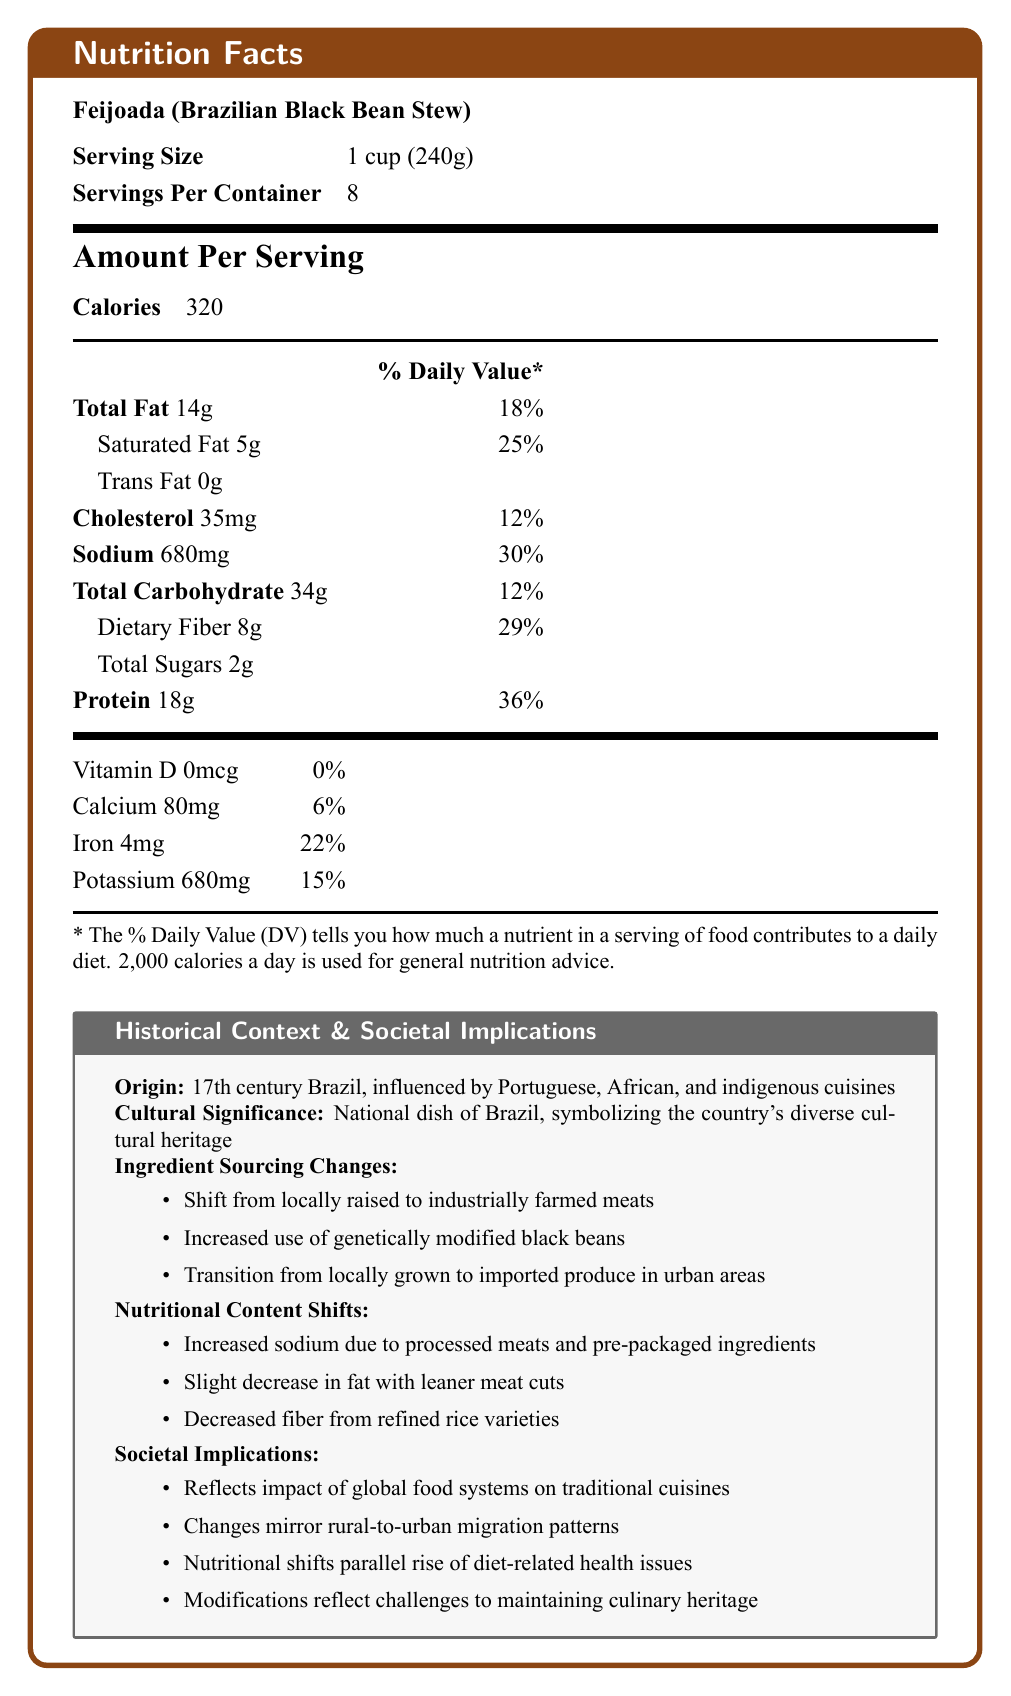what is the serving size of Feijoada (Brazilian Black Bean Stew)? The serving size is clearly mentioned in the Nutrition Facts section as "1 cup (240g)".
Answer: 1 cup (240g) how many servings are there per container? The document states "Servings Per Container: 8".
Answer: 8 what is the total fat content per serving and its daily value percentage? The document lists the total fat as 14g and the % Daily Value as 18%.
Answer: 14g, 18% how much protein is in one serving of Feijoada? The amount of protein per serving is mentioned as 18g.
Answer: 18g which nutrient has the highest % daily value? A. Iron B. Sodium C. Protein D. Saturated Fat Saturated Fat has 25% DV, which is the highest percentage compared to others listed.
Answer: D what is the historical origin of Feijoada? This information is provided under the "Historical Context" section.
Answer: 17th century Brazil, influenced by Portuguese, African, and indigenous cuisines which factors have contributed to changes in the nutritional content of Feijoada? A. Urbanization B. Globalization C. Ingredient sourcing changes D. All of the above All options (Urbanization, Globalization, and Ingredient sourcing changes) are mentioned as factors in the "Societal Implications" section.
Answer: D has the sodium content increased or decreased in modern Feijoada? The document states that sodium has increased due to the use of processed meats and pre-packaged ingredients.
Answer: Increased True or False: Feijoada has become more health-conscious over time by reducing fat content. The document mentions a slight decrease in fat due to the use of leaner cuts of meat, which indicates a move towards being more health-conscious.
Answer: True how does the shift in ingredient sourcing reflect broader societal changes? The document explains that changes in ingredient sourcing are tied to the impact of global food systems, rural-to-urban migration patterns, and the broader cultural shifts in maintaining traditional dishes.
Answer: The shift reflects the impact of globalization, urbanization, and the challenges of maintaining culinary heritage. what is the cultural significance of Feijoada in Brazil? This is stated explicitly in the "Historical Context" section.
Answer: It is the national dish of Brazil, symbolizing the country's diverse cultural heritage. how much daily value of iron does one serving provide? The % Daily Value of iron is listed as 22%.
Answer: 22% what method has seen change in the sourcing of black beans for modern Feijoada? This change is listed under the "Ingredient Sourcing Changes" section.
Answer: Increased use of genetically modified black beans describe the main changes in nutritional content over time for Feijoada. The document lists these changes under "Nutritional Content Shifts", describing how modern ingredients and cooking methods have altered the traditional nutrient profile.
Answer: Increased sodium, decreased fat, and decreased fiber. how does the nutritional content of Feijoada reflect the rise of diet-related health issues in Brazil? This is explained in the "Societal Implications" section, linking nutritional changes to health concerns.
Answer: The increased sodium and decreased fiber content parallel the rise of diet-related health issues like hypertension and obesity. what vitamins and minerals are reduced in Feijoada due to longer storage and transportation times? The document mentions a reduction in some vitamins but doesn't specify which.
Answer: Some vitamins what is the primary reason behind the decrease in dietary fiber in modern Feijoada? The "Nutritional Content Shifts" section states that decreased fiber is due to the use of refined rice.
Answer: Refined rice replacing traditional varieties 